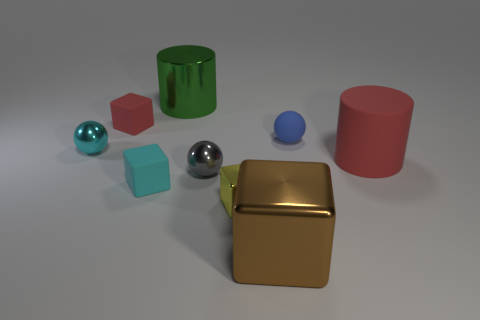Subtract all yellow metallic blocks. How many blocks are left? 3 Subtract all cylinders. How many objects are left? 7 Subtract 1 balls. How many balls are left? 2 Subtract all brown cubes. How many cubes are left? 3 Subtract 1 red cylinders. How many objects are left? 8 Subtract all purple cubes. Subtract all yellow balls. How many cubes are left? 4 Subtract all tiny yellow cylinders. Subtract all gray metallic things. How many objects are left? 8 Add 8 small blue rubber balls. How many small blue rubber balls are left? 9 Add 7 blue shiny objects. How many blue shiny objects exist? 7 